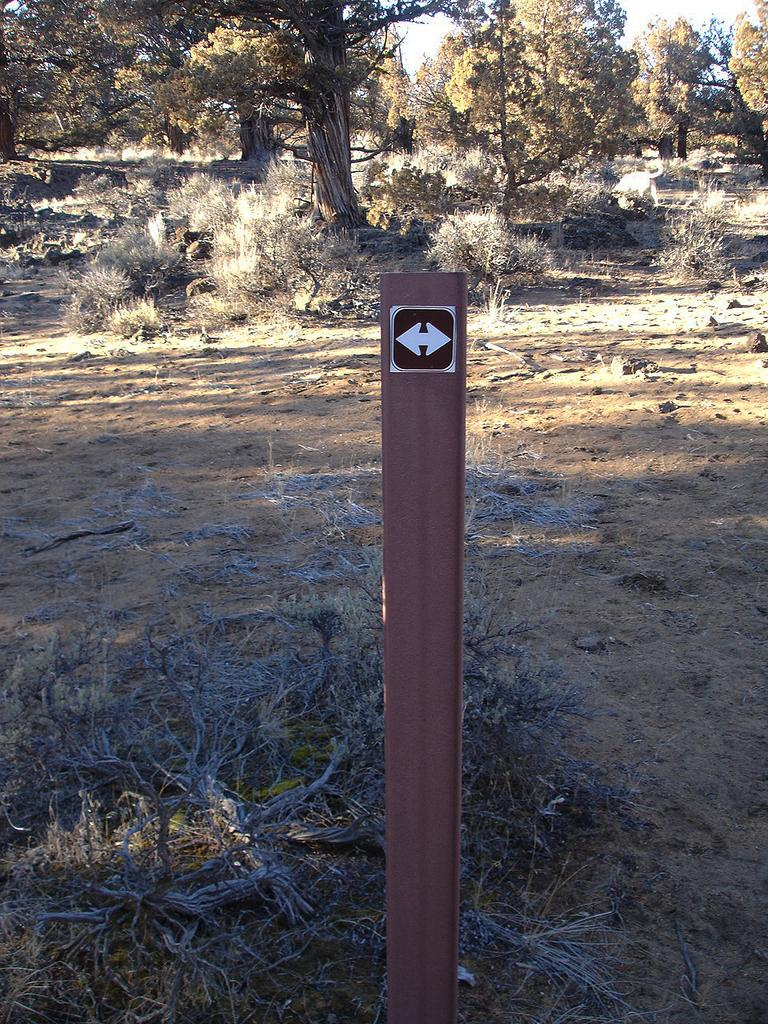What is the main object in the image? There is a pole in the image. What can be seen behind the pole? There are plants and trees behind the pole. What is visible in the background behind the pole? The sky is visible behind the pole. How many babies are playing basketball behind the pole in the image? There are no babies or basketballs present in the image. What type of teeth can be seen on the pole in the image? There are no teeth present on the pole in the image. 